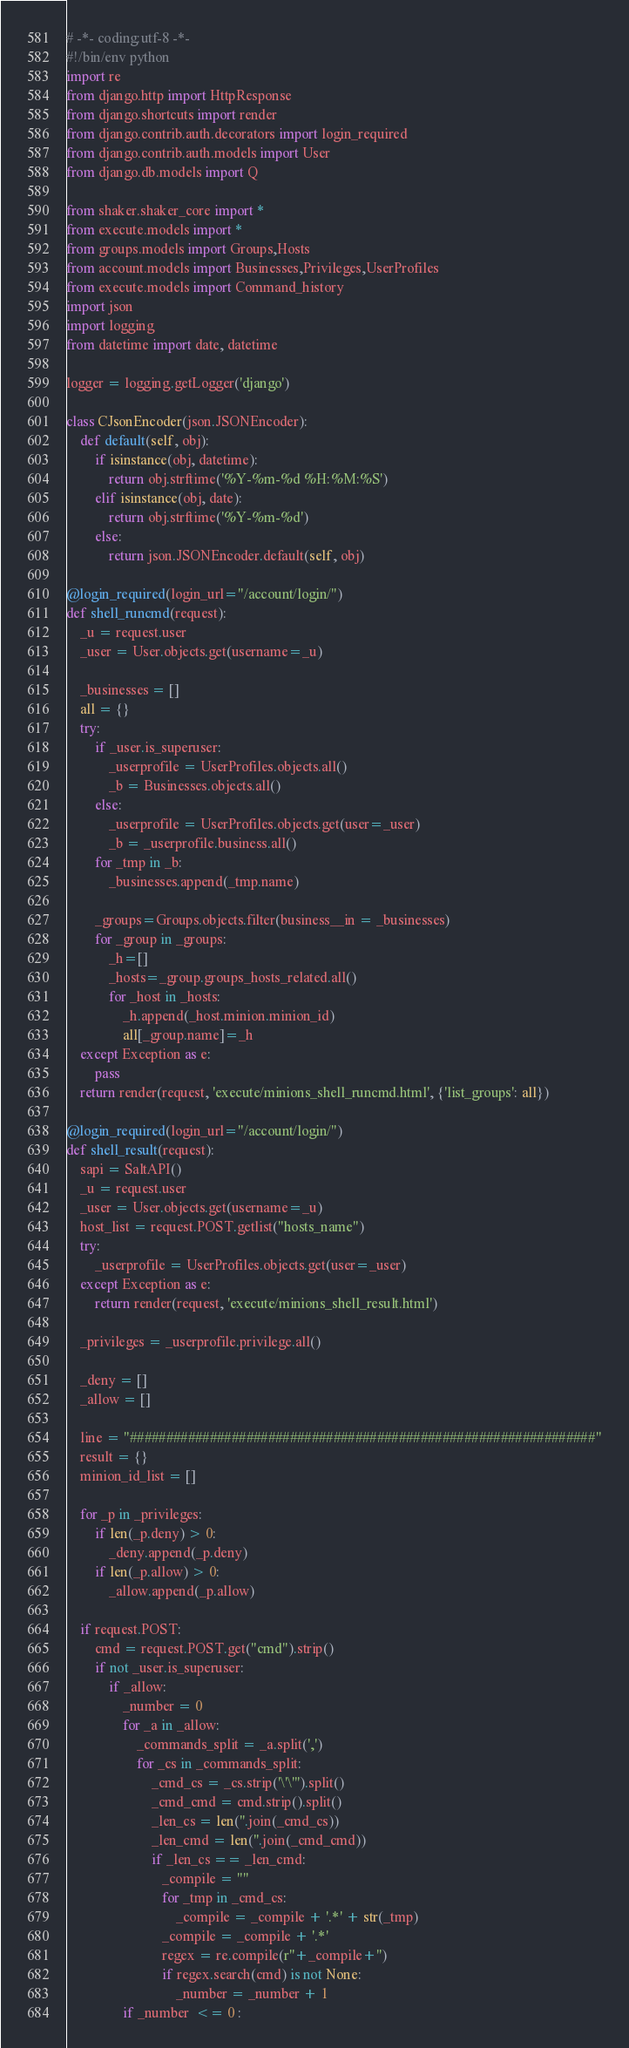<code> <loc_0><loc_0><loc_500><loc_500><_Python_># -*- coding:utf-8 -*-
#!/bin/env python
import re
from django.http import HttpResponse
from django.shortcuts import render
from django.contrib.auth.decorators import login_required
from django.contrib.auth.models import User
from django.db.models import Q

from shaker.shaker_core import *
from execute.models import *
from groups.models import Groups,Hosts
from account.models import Businesses,Privileges,UserProfiles
from execute.models import Command_history
import json
import logging
from datetime import date, datetime

logger = logging.getLogger('django')

class CJsonEncoder(json.JSONEncoder):
    def default(self, obj):
        if isinstance(obj, datetime):
            return obj.strftime('%Y-%m-%d %H:%M:%S')
        elif isinstance(obj, date):
            return obj.strftime('%Y-%m-%d')
        else:
            return json.JSONEncoder.default(self, obj)

@login_required(login_url="/account/login/")
def shell_runcmd(request):
    _u = request.user
    _user = User.objects.get(username=_u)

    _businesses = []
    all = {}
    try:
        if _user.is_superuser:
            _userprofile = UserProfiles.objects.all()
            _b = Businesses.objects.all()
        else:
            _userprofile = UserProfiles.objects.get(user=_user)
            _b = _userprofile.business.all()
        for _tmp in _b:
            _businesses.append(_tmp.name)

        _groups=Groups.objects.filter(business__in = _businesses)
        for _group in _groups:
            _h=[]
            _hosts=_group.groups_hosts_related.all()
            for _host in _hosts:
                _h.append(_host.minion.minion_id)
                all[_group.name]=_h
    except Exception as e:
        pass
    return render(request, 'execute/minions_shell_runcmd.html', {'list_groups': all})

@login_required(login_url="/account/login/")
def shell_result(request):
    sapi = SaltAPI()
    _u = request.user
    _user = User.objects.get(username=_u)
    host_list = request.POST.getlist("hosts_name")
    try:
        _userprofile = UserProfiles.objects.get(user=_user)
    except Exception as e:
        return render(request, 'execute/minions_shell_result.html')

    _privileges = _userprofile.privilege.all()

    _deny = []
    _allow = []

    line = "################################################################"
    result = {}
    minion_id_list = []
    
    for _p in _privileges:
        if len(_p.deny) > 0:
            _deny.append(_p.deny)  
        if len(_p.allow) > 0:
            _allow.append(_p.allow)

    if request.POST:
        cmd = request.POST.get("cmd").strip()
        if not _user.is_superuser:
            if _allow:
                _number = 0
                for _a in _allow:
                    _commands_split = _a.split(',')
                    for _cs in _commands_split:
                        _cmd_cs = _cs.strip('\'\"').split()
                        _cmd_cmd = cmd.strip().split()
                        _len_cs = len(''.join(_cmd_cs))
                        _len_cmd = len(''.join(_cmd_cmd))
                        if _len_cs == _len_cmd:
                           _compile = ""
                           for _tmp in _cmd_cs:
                               _compile = _compile + '.*' + str(_tmp)
                           _compile = _compile + '.*'
                           regex = re.compile(r''+_compile+'')
                           if regex.search(cmd) is not None:
                               _number = _number + 1
                if _number  <= 0 :</code> 